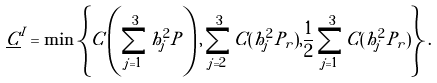<formula> <loc_0><loc_0><loc_500><loc_500>\underline { C } ^ { I } & = \min \left \{ C \left ( \sum _ { j = 1 } ^ { 3 } h _ { j } ^ { 2 } P \right ) , \sum _ { j = 2 } ^ { 3 } C ( h _ { j } ^ { 2 } P _ { r } ) , \frac { 1 } { 2 } \sum _ { j = 1 } ^ { 3 } C ( h _ { j } ^ { 2 } P _ { r } ) \right \} .</formula> 